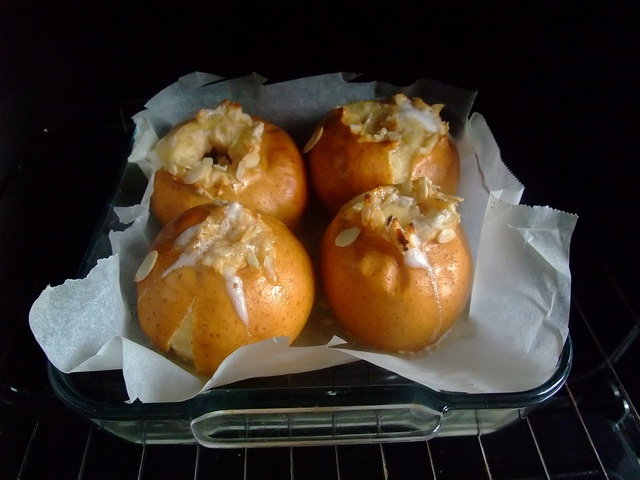Describe the objects in this image and their specific colors. I can see oven in black, darkgray, gray, olive, and maroon tones, orange in black, olive, tan, orange, and maroon tones, apple in black, olive, tan, orange, and maroon tones, apple in black, olive, tan, and maroon tones, and apple in black, maroon, olive, and tan tones in this image. 